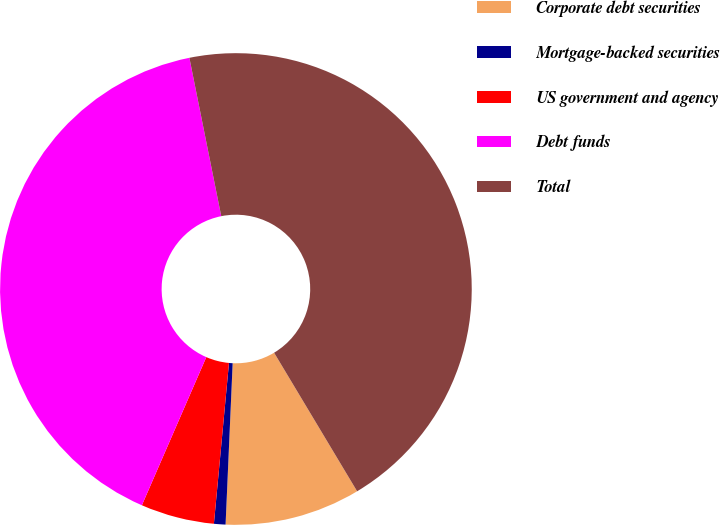<chart> <loc_0><loc_0><loc_500><loc_500><pie_chart><fcel>Corporate debt securities<fcel>Mortgage-backed securities<fcel>US government and agency<fcel>Debt funds<fcel>Total<nl><fcel>9.29%<fcel>0.79%<fcel>5.04%<fcel>40.31%<fcel>44.57%<nl></chart> 